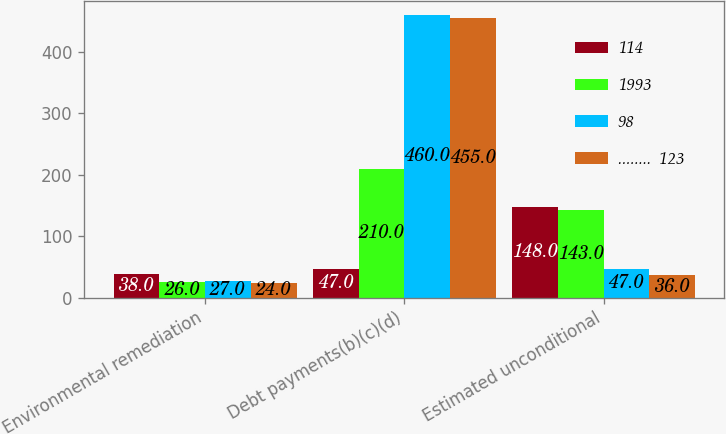Convert chart to OTSL. <chart><loc_0><loc_0><loc_500><loc_500><stacked_bar_chart><ecel><fcel>Environmental remediation<fcel>Debt payments(b)(c)(d)<fcel>Estimated unconditional<nl><fcel>114<fcel>38<fcel>47<fcel>148<nl><fcel>1993<fcel>26<fcel>210<fcel>143<nl><fcel>98<fcel>27<fcel>460<fcel>47<nl><fcel>........  123<fcel>24<fcel>455<fcel>36<nl></chart> 